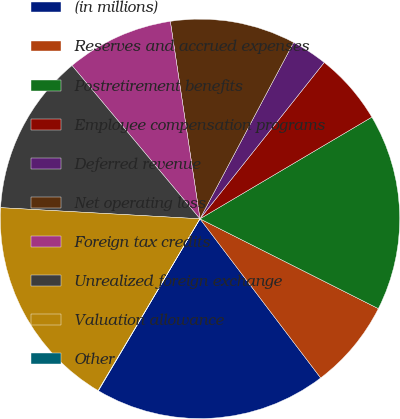Convert chart to OTSL. <chart><loc_0><loc_0><loc_500><loc_500><pie_chart><fcel>(in millions)<fcel>Reserves and accrued expenses<fcel>Postretirement benefits<fcel>Employee compensation programs<fcel>Deferred revenue<fcel>Net operating loss<fcel>Foreign tax credits<fcel>Unrealized foreign exchange<fcel>Valuation allowance<fcel>Other<nl><fcel>18.82%<fcel>7.25%<fcel>15.93%<fcel>5.81%<fcel>2.92%<fcel>10.14%<fcel>8.7%<fcel>13.04%<fcel>17.37%<fcel>0.03%<nl></chart> 